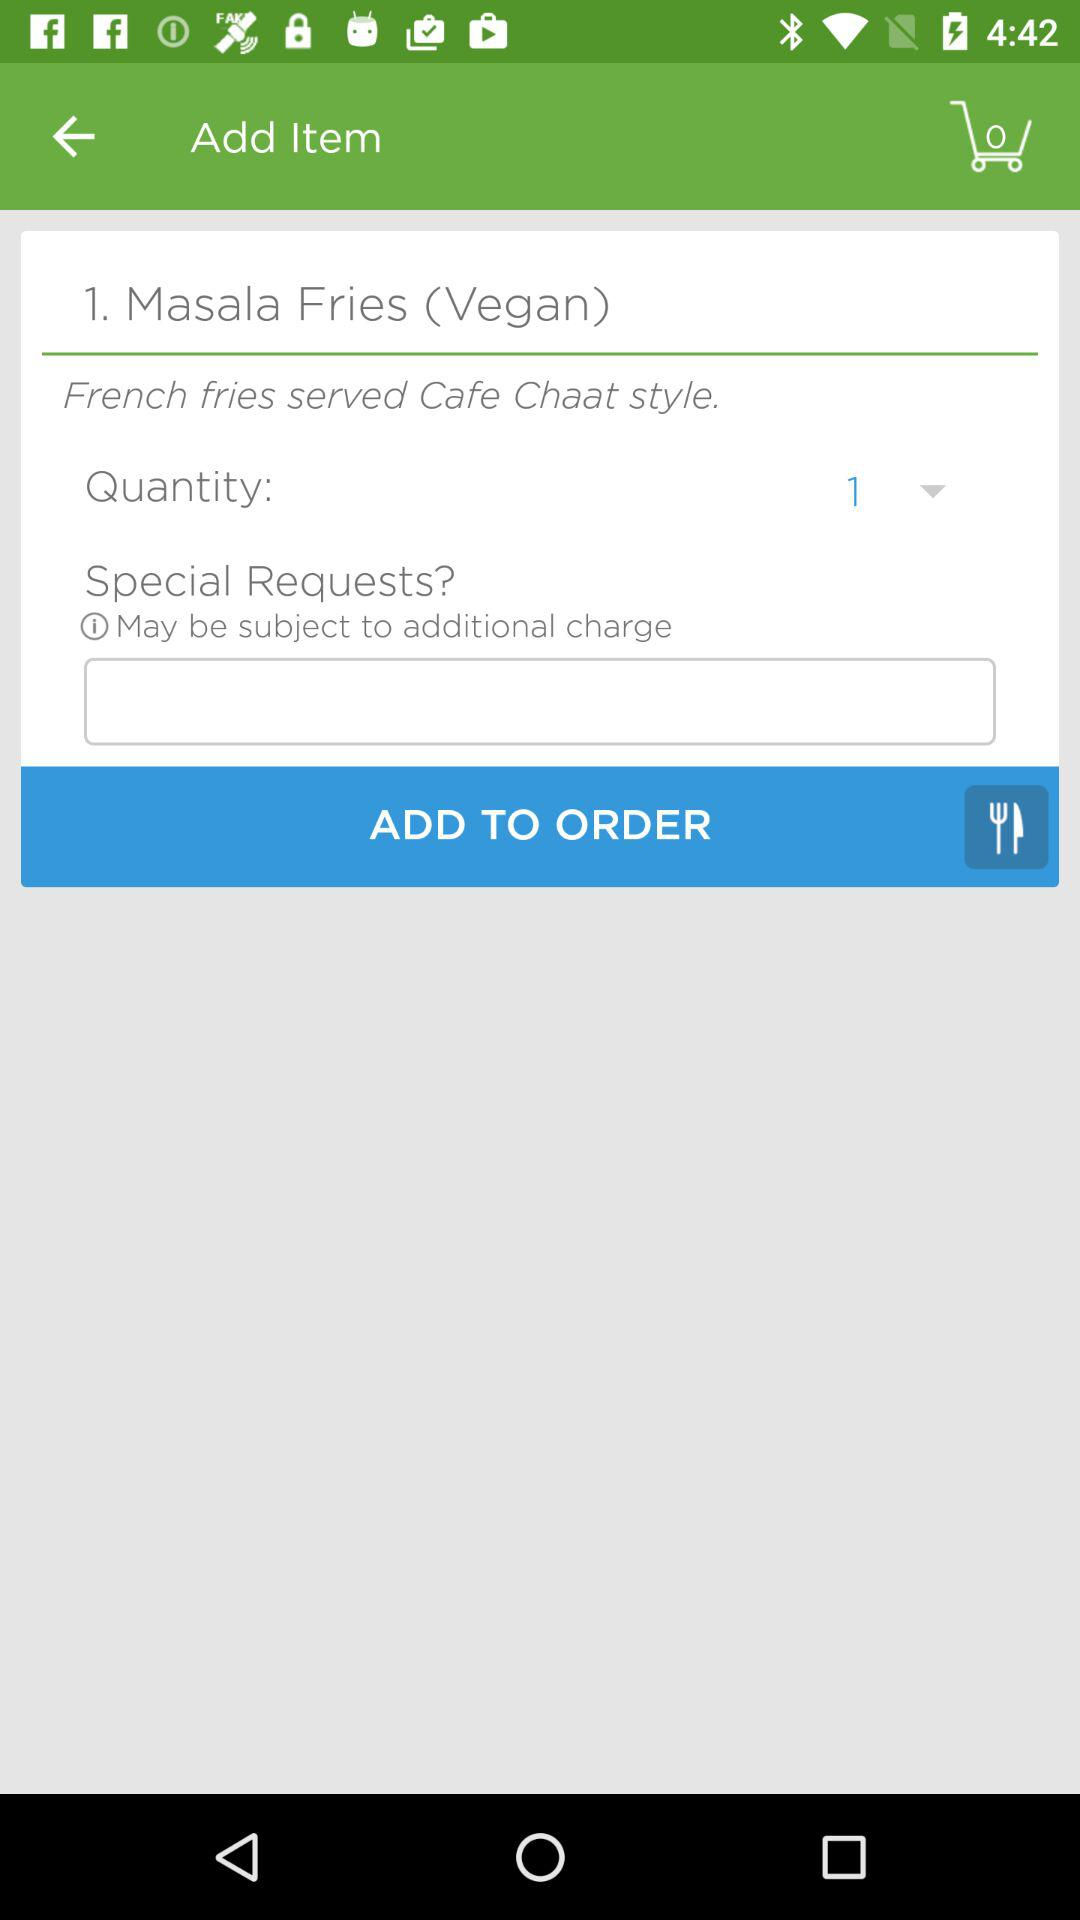How many Masala Fries (Vegan) items are in the cart?
Answer the question using a single word or phrase. 1 